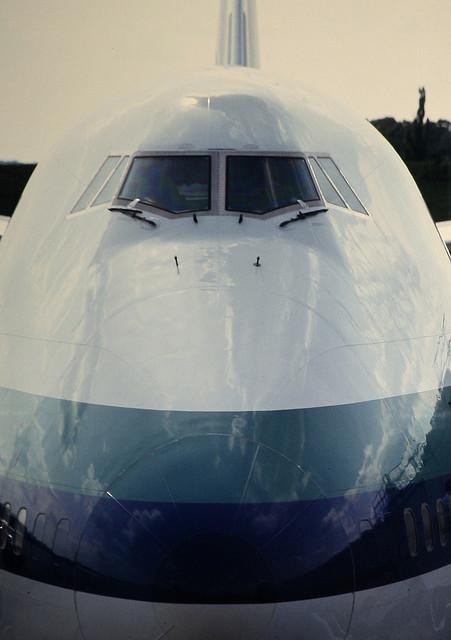Is this plane in the air?
Keep it brief. No. Is this a space shuttle?
Concise answer only. No. How many windows are visible?
Write a very short answer. 6. 